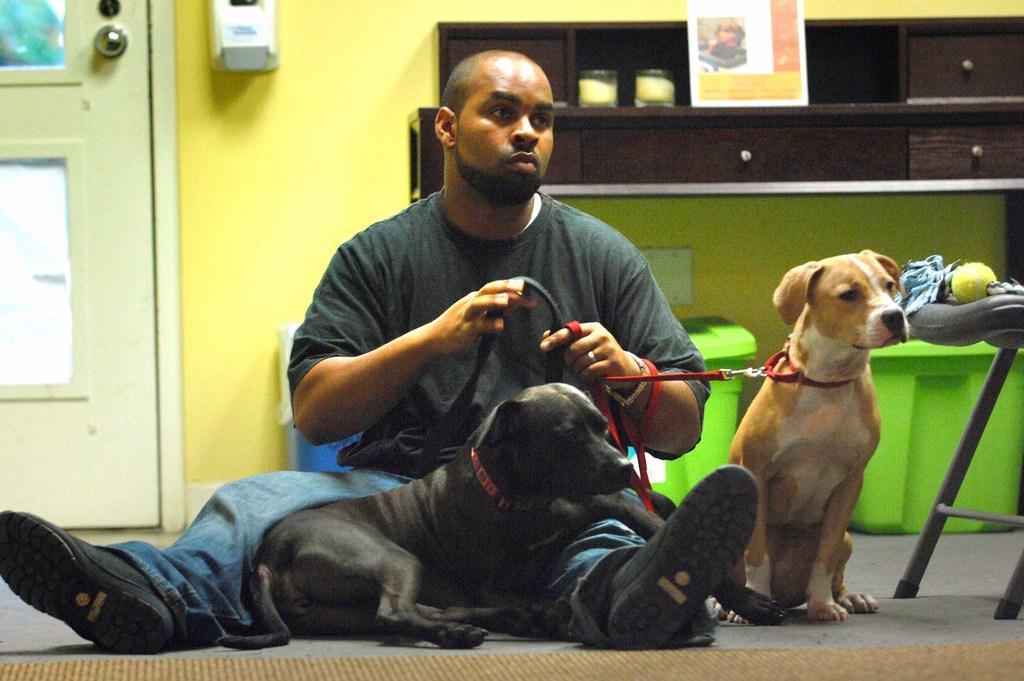Can you describe this image briefly? In the above picture there is a person sitting on the floor holding the dogs. One dog is brown in color which is right side to the picture and the other dog is black in color which is sitting in front of the person front of the person. The person is having is wearing a black t shirt and a blue jeans with black shoes in the background of the picture i could see a wall which is yellow in color and a white door and there is a tissue sanitize box. In the right side of the picture in the background there is a dark brown colored cabinet in which is hanging to the wall. There is candle glasses in the cabinets and on the cabinet there is a poster which is stick to it. On the floor there is brown colored carpet, and near the brown colored dog there is chair, on that chair i could see a yellow colored ball. Back of the person there are three different boxes two of them are green in color having a lid on them and the other box is blue in color 